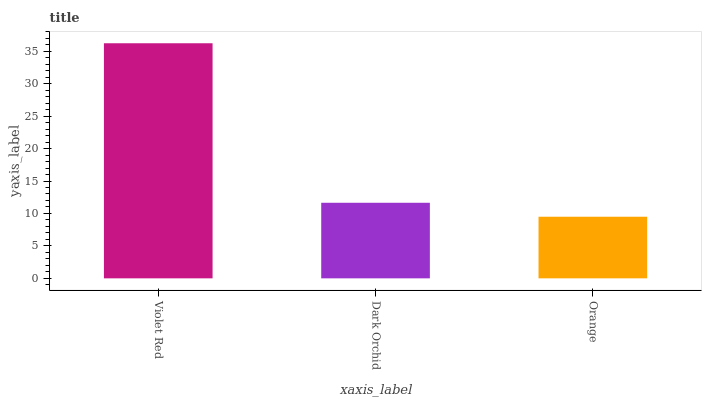Is Orange the minimum?
Answer yes or no. Yes. Is Violet Red the maximum?
Answer yes or no. Yes. Is Dark Orchid the minimum?
Answer yes or no. No. Is Dark Orchid the maximum?
Answer yes or no. No. Is Violet Red greater than Dark Orchid?
Answer yes or no. Yes. Is Dark Orchid less than Violet Red?
Answer yes or no. Yes. Is Dark Orchid greater than Violet Red?
Answer yes or no. No. Is Violet Red less than Dark Orchid?
Answer yes or no. No. Is Dark Orchid the high median?
Answer yes or no. Yes. Is Dark Orchid the low median?
Answer yes or no. Yes. Is Violet Red the high median?
Answer yes or no. No. Is Violet Red the low median?
Answer yes or no. No. 